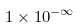<formula> <loc_0><loc_0><loc_500><loc_500>1 \times 1 0 ^ { - \infty }</formula> 